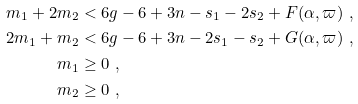Convert formula to latex. <formula><loc_0><loc_0><loc_500><loc_500>m _ { 1 } + 2 m _ { 2 } & < 6 g - 6 + 3 n - s _ { 1 } - 2 s _ { 2 } + F ( \alpha , \varpi ) \ , \\ 2 m _ { 1 } + m _ { 2 } & < 6 g - 6 + 3 n - 2 s _ { 1 } - s _ { 2 } + G ( \alpha , \varpi ) \ , \\ m _ { 1 } & \geq 0 \ , \\ m _ { 2 } & \geq 0 \ ,</formula> 